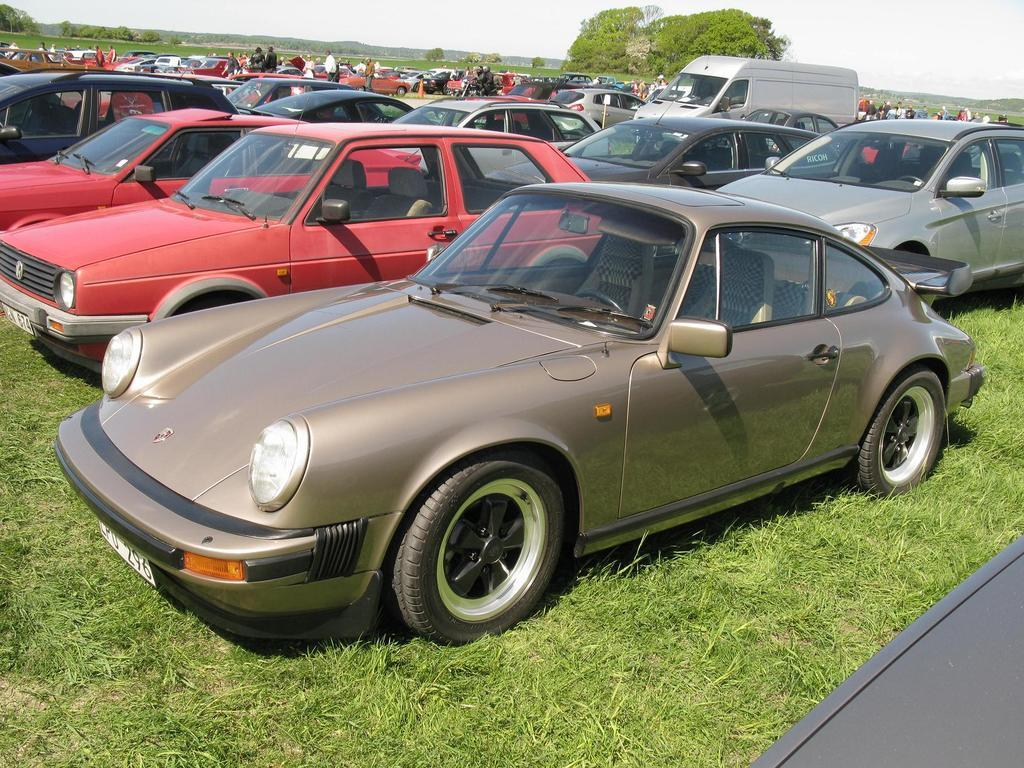What types of objects can be seen in the image? There are vehicles in the image. What are the people in the image doing? The people are on the grass in the image. What can be seen in the background of the image? There are trees and the sky visible in the background of the image. What is the thought process of the water in the image? There is no water present in the image, so it is not possible to determine its thought process. 